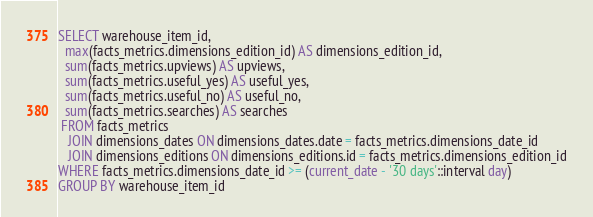<code> <loc_0><loc_0><loc_500><loc_500><_SQL_>SELECT warehouse_item_id,
  max(facts_metrics.dimensions_edition_id) AS dimensions_edition_id,
  sum(facts_metrics.upviews) AS upviews,
  sum(facts_metrics.useful_yes) AS useful_yes,
  sum(facts_metrics.useful_no) AS useful_no,
  sum(facts_metrics.searches) AS searches
 FROM facts_metrics
   JOIN dimensions_dates ON dimensions_dates.date = facts_metrics.dimensions_date_id
   JOIN dimensions_editions ON dimensions_editions.id = facts_metrics.dimensions_edition_id
WHERE facts_metrics.dimensions_date_id >= (current_date - '30 days'::interval day)
GROUP BY warehouse_item_id</code> 